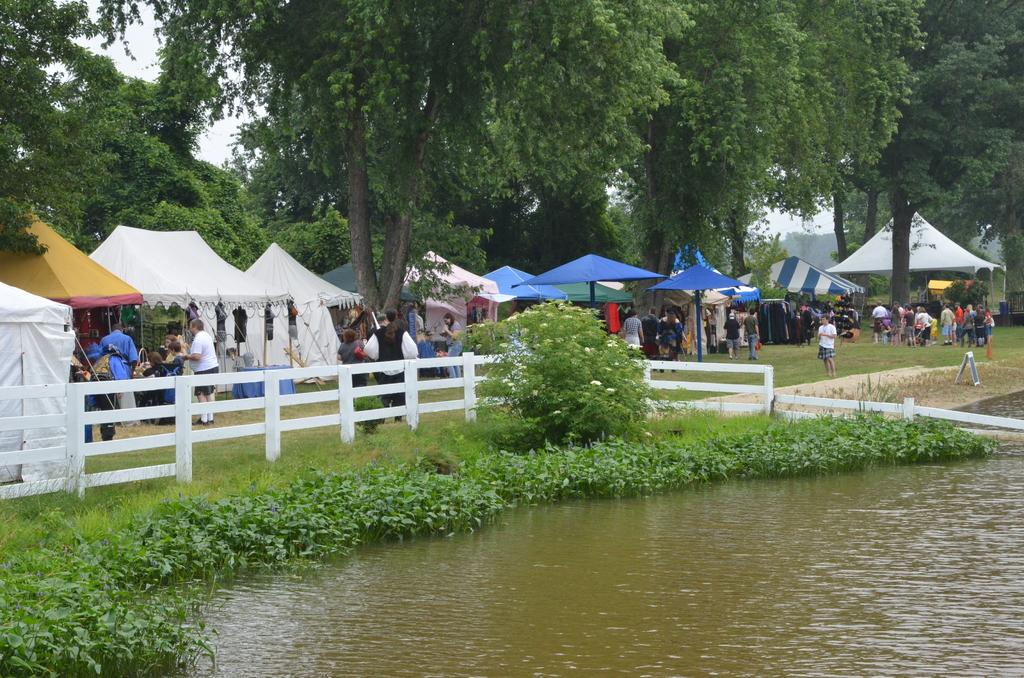What is one of the natural elements present in the image? There is water in the image. What type of vegetation can be seen in the image? There is grass and trees in the image. What type of temporary shelter is visible in the image? There are tents in the image. Are there any people present in the image? Yes, there are people standing in the image. What language are the people speaking in the image? The provided facts do not mention any specific language being spoken in the image. What type of flesh can be seen on the trees in the image? There is no flesh visible on the trees in the image; they are covered with bark. 